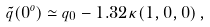<formula> <loc_0><loc_0><loc_500><loc_500>\tilde { q } ( 0 ^ { o } ) \simeq { q } _ { 0 } - 1 . 3 2 \kappa ( 1 , 0 , 0 ) \, ,</formula> 